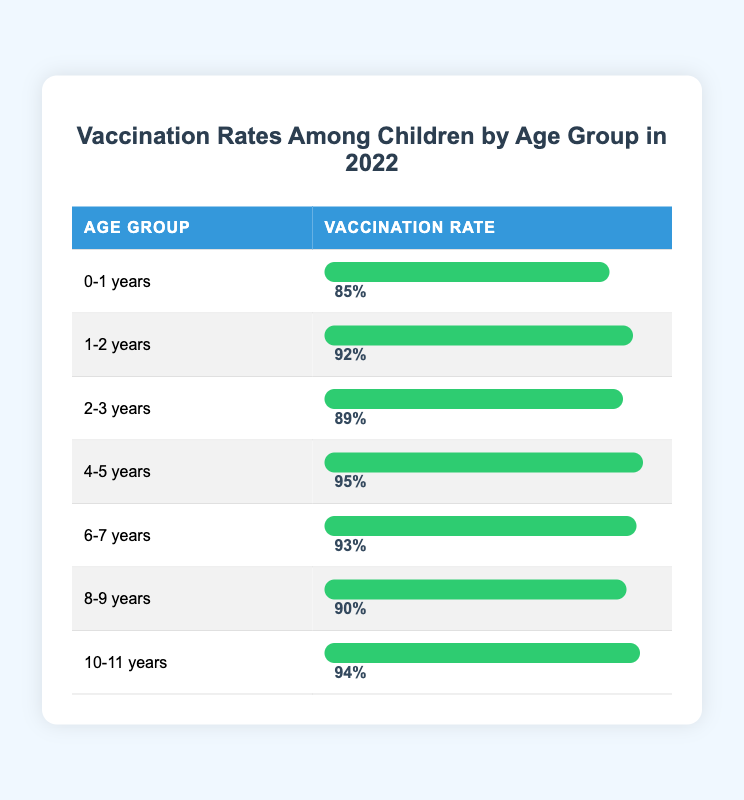What is the vaccination rate for the age group 4-5 years? According to the table, the vaccination rate specifically for the age group 4-5 years is listed as 95%.
Answer: 95% Which age group has the highest vaccination rate? By examining the vaccination rates in each age group, we see that the highest rate is 95% for the age group 4-5 years.
Answer: 4-5 years What is the average vaccination rate for children aged 0-3 years? The vaccination rates for children aged 0-3 years are 85% (0-1 years), 92% (1-2 years), and 89% (2-3 years). To find the average, we sum these rates: 85 + 92 + 89 = 266, then divide by 3, which equals approximately 88.67%.
Answer: 88.67% Are there any age groups with vaccination rates below 90%? By reviewing the table, we find that the only age group with a vaccination rate below 90% is 0-1 years, which has a rate of 85%. Therefore, the answer is yes.
Answer: Yes What is the difference in vaccination rates between the age groups 6-7 years and 10-11 years? The vaccination rate for 6-7 years is 93% and for 10-11 years, it is 94%. To determine the difference, we subtract the two rates: 94% - 93% = 1%.
Answer: 1% What is the cumulative vaccination rate for children aged 8-11 years? The vaccination rates for these age groups are as follows: 8-9 years has a rate of 90% and 10-11 years has a rate of 94%. To get the cumulative rate, we sum these two rates: 90% + 94% = 184%.
Answer: 184% Is the vaccination rate for 1-2 years higher than that for 8-9 years? The vaccination rate for 1-2 years is 92%, while for 8-9 years it is 90%. Since 92% is greater than 90%, the answer is yes.
Answer: Yes Which age group has a vaccination rate closer to 90% when considering the 6-7 years and 8-9 years groups? The vaccination rate for 6-7 years is 93% and for 8-9 years it is 90%. Since 90% is closer to 90% compared to 93%, the age group closer to 90% is 8-9 years.
Answer: 8-9 years 